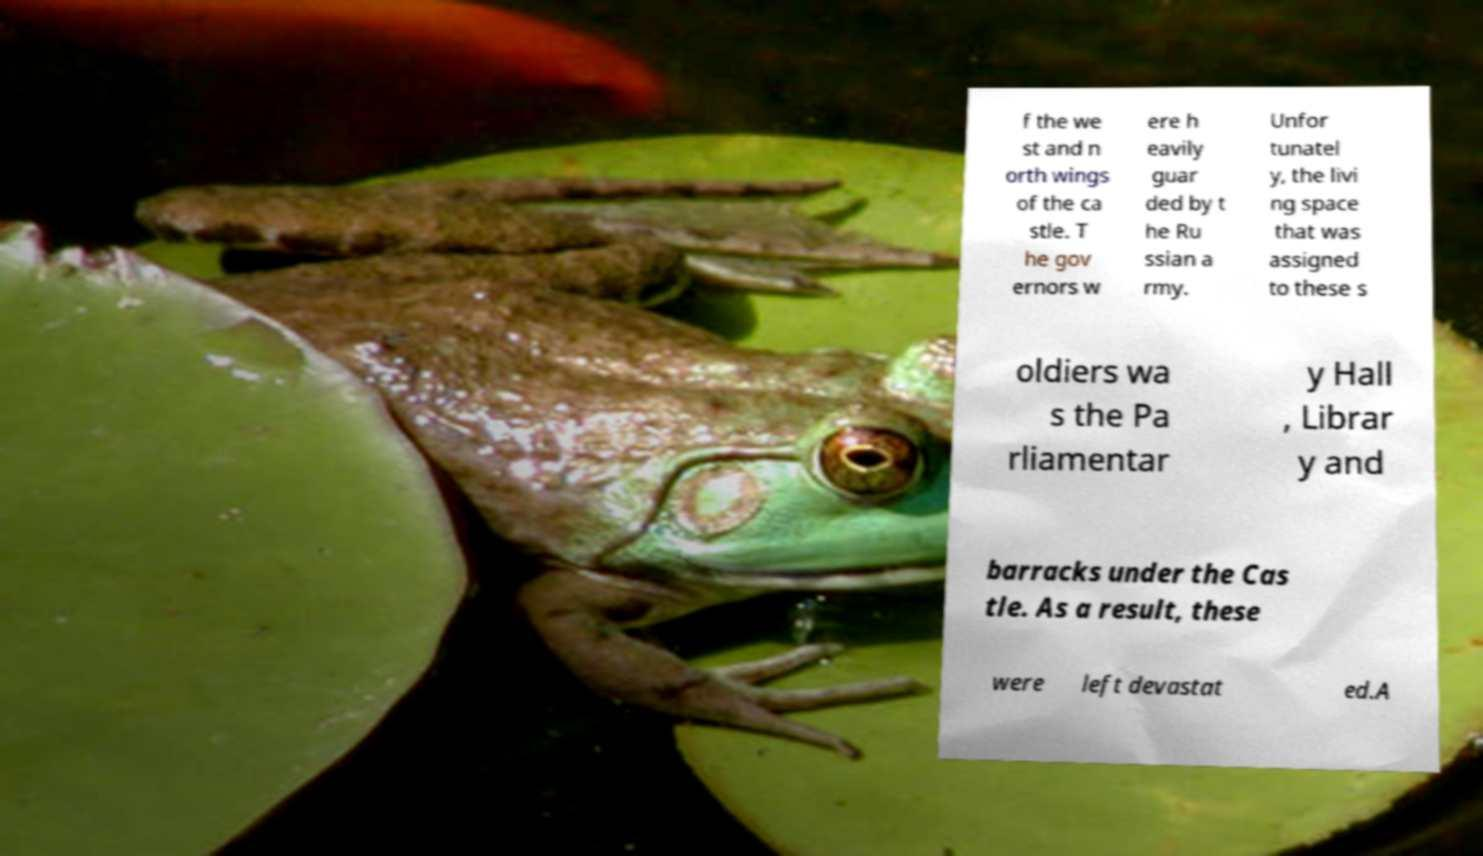Please identify and transcribe the text found in this image. f the we st and n orth wings of the ca stle. T he gov ernors w ere h eavily guar ded by t he Ru ssian a rmy. Unfor tunatel y, the livi ng space that was assigned to these s oldiers wa s the Pa rliamentar y Hall , Librar y and barracks under the Cas tle. As a result, these were left devastat ed.A 